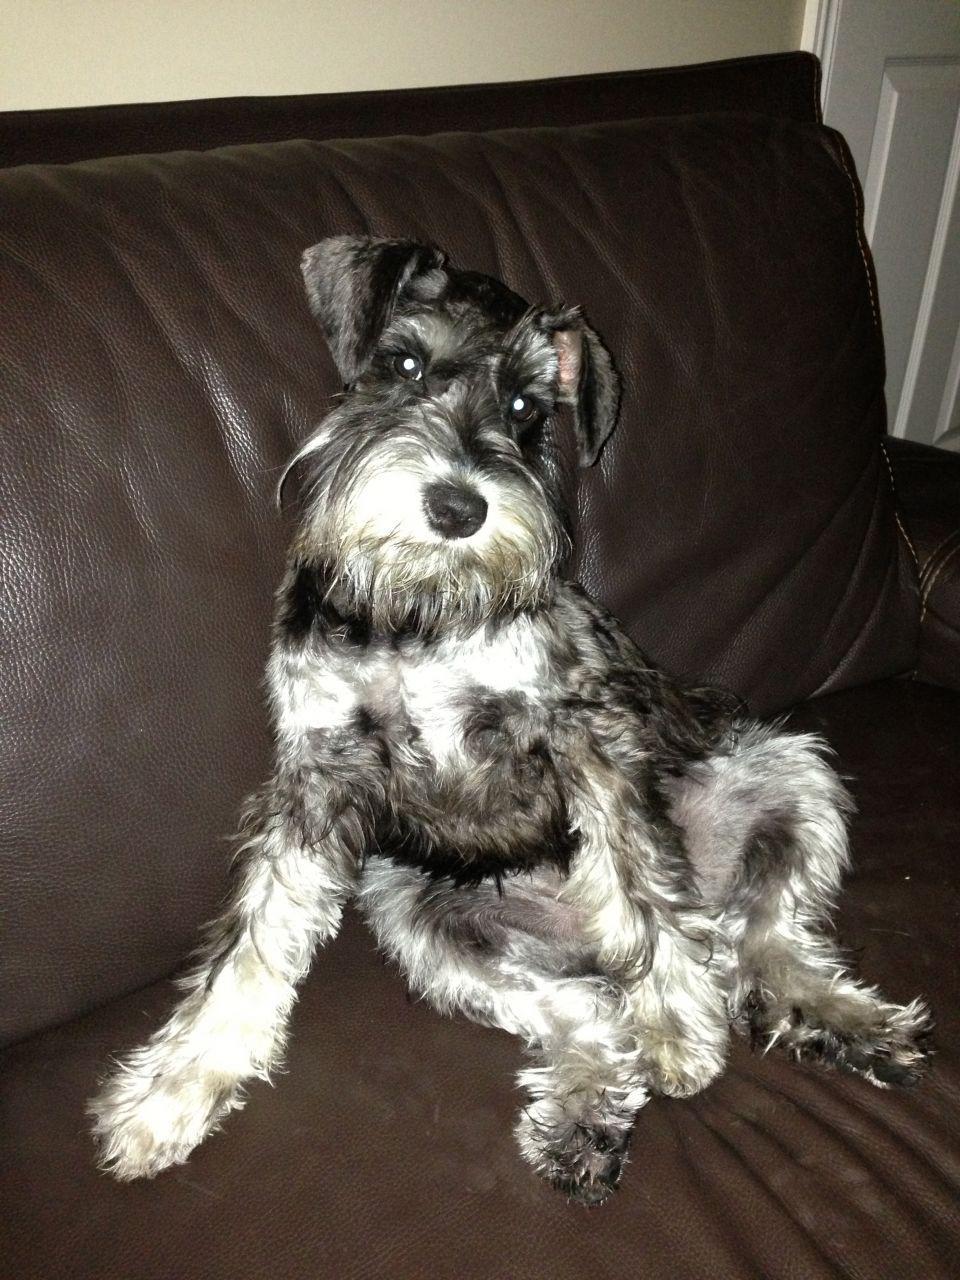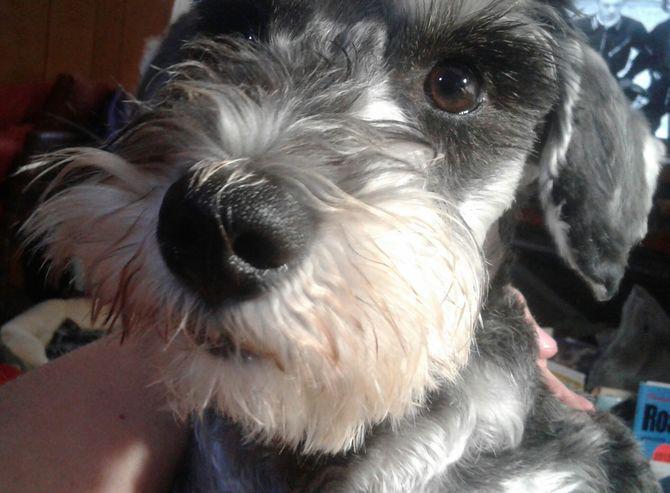The first image is the image on the left, the second image is the image on the right. Evaluate the accuracy of this statement regarding the images: "there is a dog sitting on a chair indoors". Is it true? Answer yes or no. Yes. The first image is the image on the left, the second image is the image on the right. Analyze the images presented: Is the assertion "Exactly one dog is sitting." valid? Answer yes or no. Yes. 